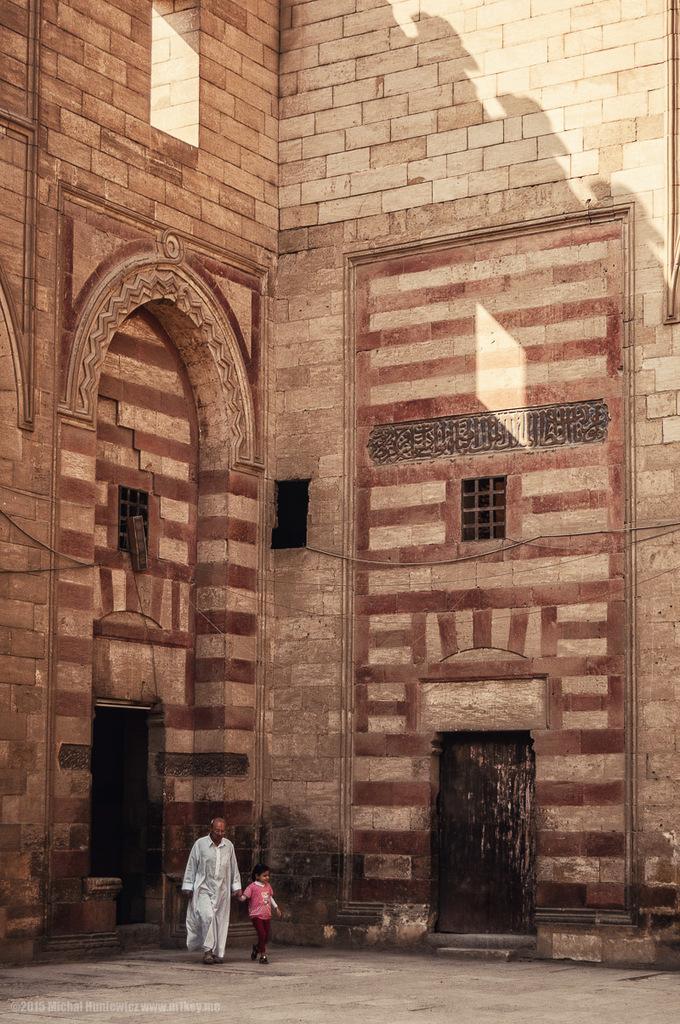How would you summarize this image in a sentence or two? In this image there is an old man walking on the floor along with the kid. In the background there is a building. On the right side bottom there is a door. 